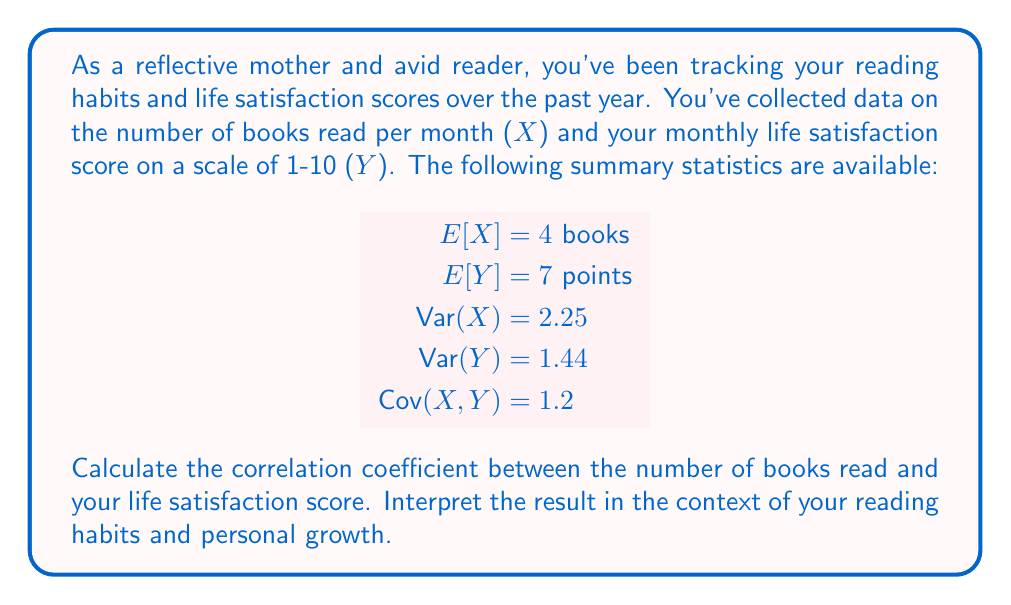Solve this math problem. To solve this problem, we'll use the formula for the correlation coefficient:

$$ \rho_{X,Y} = \frac{\text{Cov}(X,Y)}{\sqrt{\text{Var}(X) \cdot \text{Var}(Y)}} $$

Let's break down the solution step-by-step:

1. We're given the following values:
   $\text{Cov}(X,Y) = 1.2$
   $\text{Var}(X) = 2.25$
   $\text{Var}(Y) = 1.44$

2. Substitute these values into the correlation coefficient formula:

   $$ \rho_{X,Y} = \frac{1.2}{\sqrt{2.25 \cdot 1.44}} $$

3. Calculate the denominator:
   $\sqrt{2.25 \cdot 1.44} = \sqrt{3.24} = 1.8$

4. Divide the numerator by the denominator:

   $$ \rho_{X,Y} = \frac{1.2}{1.8} = \frac{2}{3} \approx 0.667 $$

Interpretation:
The correlation coefficient of approximately 0.667 indicates a moderately strong positive correlation between the number of books read and life satisfaction scores. This suggests that, as a reflective mother and avid reader, there is a tendency for your life satisfaction to increase as you read more books. 

This positive correlation aligns with the philosophical and reflective nature described in your persona. Reading more books may contribute to personal growth, provide new perspectives, and offer moments of reflection, all of which could positively impact your overall life satisfaction.

However, it's important to note that correlation does not imply causation. Other factors may influence both reading habits and life satisfaction, and the relationship between the two variables may be more complex than a simple cause-and-effect relationship.
Answer: The correlation coefficient is $\frac{2}{3} \approx 0.667$, indicating a moderately strong positive correlation between the number of books read and life satisfaction scores. 